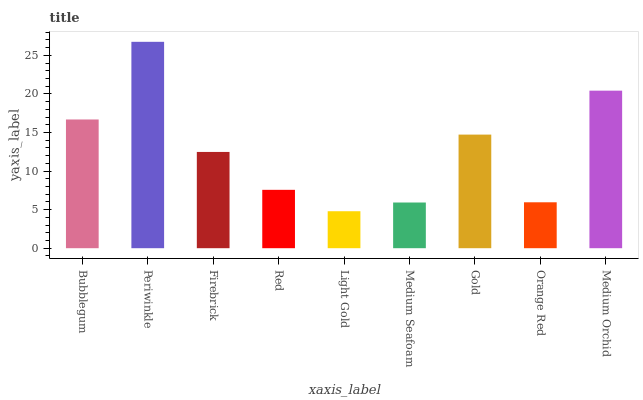Is Light Gold the minimum?
Answer yes or no. Yes. Is Periwinkle the maximum?
Answer yes or no. Yes. Is Firebrick the minimum?
Answer yes or no. No. Is Firebrick the maximum?
Answer yes or no. No. Is Periwinkle greater than Firebrick?
Answer yes or no. Yes. Is Firebrick less than Periwinkle?
Answer yes or no. Yes. Is Firebrick greater than Periwinkle?
Answer yes or no. No. Is Periwinkle less than Firebrick?
Answer yes or no. No. Is Firebrick the high median?
Answer yes or no. Yes. Is Firebrick the low median?
Answer yes or no. Yes. Is Gold the high median?
Answer yes or no. No. Is Light Gold the low median?
Answer yes or no. No. 